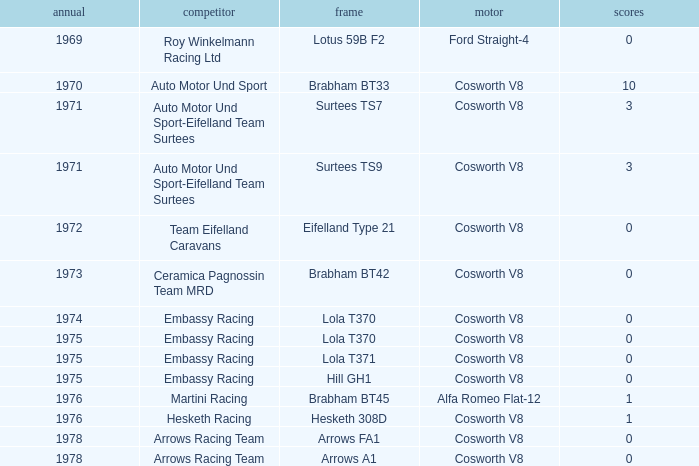In 1970, what entrant had a cosworth v8 engine? Auto Motor Und Sport. 